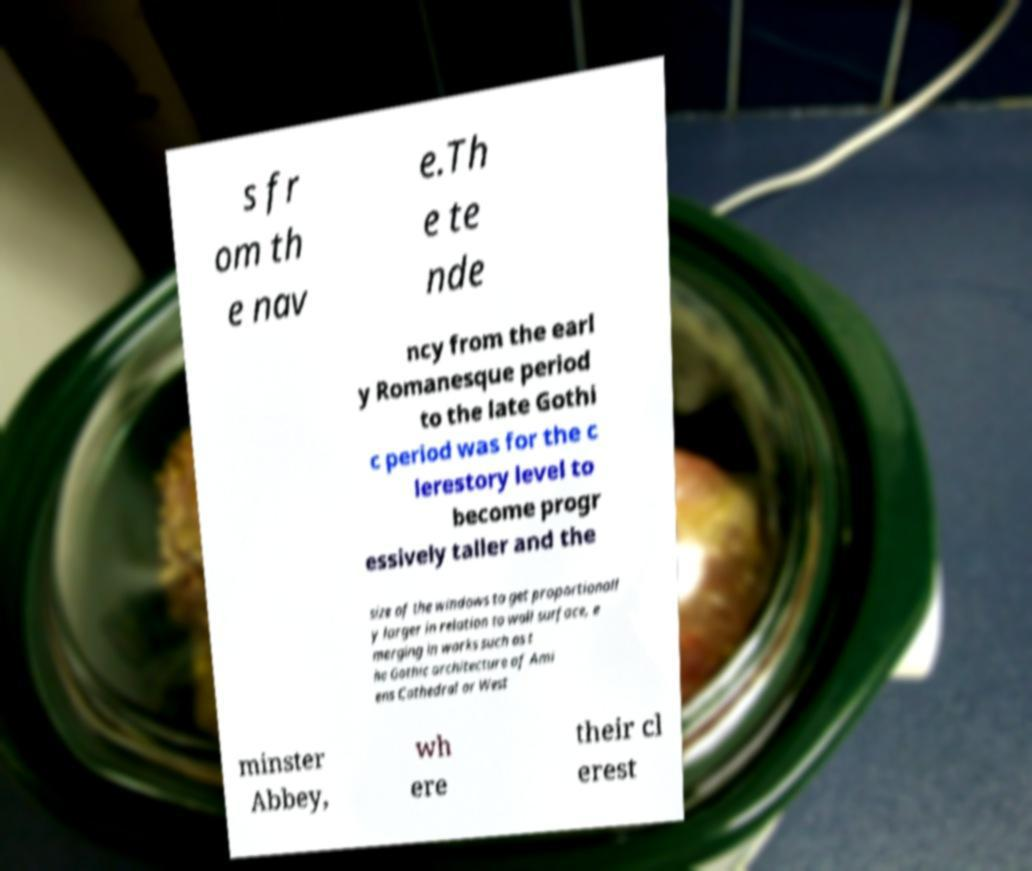Please read and relay the text visible in this image. What does it say? s fr om th e nav e.Th e te nde ncy from the earl y Romanesque period to the late Gothi c period was for the c lerestory level to become progr essively taller and the size of the windows to get proportionall y larger in relation to wall surface, e merging in works such as t he Gothic architecture of Ami ens Cathedral or West minster Abbey, wh ere their cl erest 